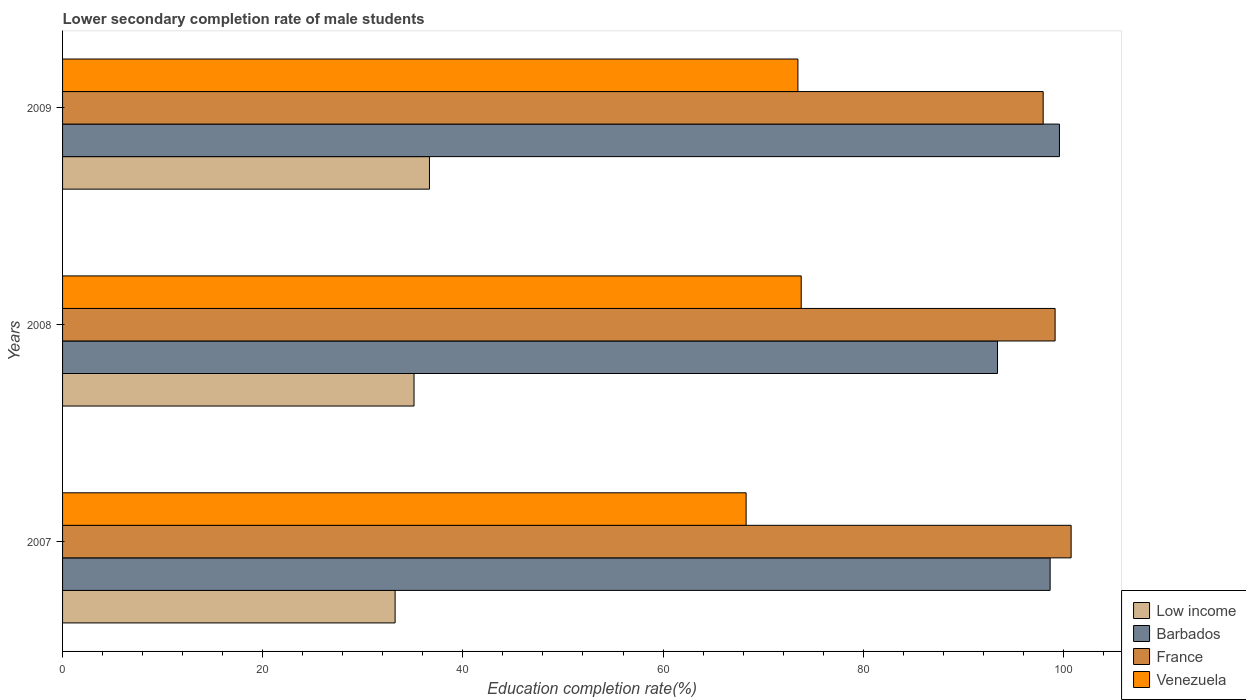How many bars are there on the 1st tick from the top?
Keep it short and to the point. 4. How many bars are there on the 2nd tick from the bottom?
Your answer should be very brief. 4. What is the label of the 1st group of bars from the top?
Provide a succinct answer. 2009. In how many cases, is the number of bars for a given year not equal to the number of legend labels?
Your answer should be compact. 0. What is the lower secondary completion rate of male students in Venezuela in 2007?
Provide a succinct answer. 68.3. Across all years, what is the maximum lower secondary completion rate of male students in Low income?
Your response must be concise. 36.66. Across all years, what is the minimum lower secondary completion rate of male students in Low income?
Keep it short and to the point. 33.23. In which year was the lower secondary completion rate of male students in France minimum?
Provide a succinct answer. 2009. What is the total lower secondary completion rate of male students in Barbados in the graph?
Offer a terse response. 291.71. What is the difference between the lower secondary completion rate of male students in Barbados in 2008 and that in 2009?
Ensure brevity in your answer.  -6.19. What is the difference between the lower secondary completion rate of male students in Venezuela in 2009 and the lower secondary completion rate of male students in Low income in 2007?
Give a very brief answer. 40.25. What is the average lower secondary completion rate of male students in Low income per year?
Offer a terse response. 35. In the year 2007, what is the difference between the lower secondary completion rate of male students in Barbados and lower secondary completion rate of male students in Low income?
Provide a succinct answer. 65.45. In how many years, is the lower secondary completion rate of male students in Low income greater than 80 %?
Your answer should be very brief. 0. What is the ratio of the lower secondary completion rate of male students in Barbados in 2008 to that in 2009?
Your response must be concise. 0.94. Is the difference between the lower secondary completion rate of male students in Barbados in 2008 and 2009 greater than the difference between the lower secondary completion rate of male students in Low income in 2008 and 2009?
Offer a very short reply. No. What is the difference between the highest and the second highest lower secondary completion rate of male students in Venezuela?
Your answer should be compact. 0.33. What is the difference between the highest and the lowest lower secondary completion rate of male students in Venezuela?
Make the answer very short. 5.5. Is the sum of the lower secondary completion rate of male students in Low income in 2007 and 2009 greater than the maximum lower secondary completion rate of male students in Barbados across all years?
Offer a very short reply. No. Is it the case that in every year, the sum of the lower secondary completion rate of male students in Low income and lower secondary completion rate of male students in Venezuela is greater than the sum of lower secondary completion rate of male students in France and lower secondary completion rate of male students in Barbados?
Keep it short and to the point. Yes. What does the 4th bar from the bottom in 2009 represents?
Provide a short and direct response. Venezuela. Is it the case that in every year, the sum of the lower secondary completion rate of male students in Venezuela and lower secondary completion rate of male students in France is greater than the lower secondary completion rate of male students in Low income?
Make the answer very short. Yes. How many bars are there?
Ensure brevity in your answer.  12. Are all the bars in the graph horizontal?
Provide a short and direct response. Yes. What is the difference between two consecutive major ticks on the X-axis?
Your answer should be compact. 20. Does the graph contain any zero values?
Offer a terse response. No. How many legend labels are there?
Make the answer very short. 4. What is the title of the graph?
Provide a succinct answer. Lower secondary completion rate of male students. What is the label or title of the X-axis?
Provide a succinct answer. Education completion rate(%). What is the label or title of the Y-axis?
Provide a short and direct response. Years. What is the Education completion rate(%) in Low income in 2007?
Give a very brief answer. 33.23. What is the Education completion rate(%) in Barbados in 2007?
Provide a short and direct response. 98.68. What is the Education completion rate(%) of France in 2007?
Make the answer very short. 100.78. What is the Education completion rate(%) in Venezuela in 2007?
Your answer should be compact. 68.3. What is the Education completion rate(%) in Low income in 2008?
Offer a terse response. 35.12. What is the Education completion rate(%) in Barbados in 2008?
Your response must be concise. 93.42. What is the Education completion rate(%) in France in 2008?
Give a very brief answer. 99.18. What is the Education completion rate(%) of Venezuela in 2008?
Give a very brief answer. 73.81. What is the Education completion rate(%) of Low income in 2009?
Give a very brief answer. 36.66. What is the Education completion rate(%) of Barbados in 2009?
Offer a terse response. 99.61. What is the Education completion rate(%) in France in 2009?
Your answer should be very brief. 97.98. What is the Education completion rate(%) of Venezuela in 2009?
Keep it short and to the point. 73.48. Across all years, what is the maximum Education completion rate(%) of Low income?
Make the answer very short. 36.66. Across all years, what is the maximum Education completion rate(%) of Barbados?
Provide a succinct answer. 99.61. Across all years, what is the maximum Education completion rate(%) in France?
Offer a terse response. 100.78. Across all years, what is the maximum Education completion rate(%) of Venezuela?
Ensure brevity in your answer.  73.81. Across all years, what is the minimum Education completion rate(%) of Low income?
Your response must be concise. 33.23. Across all years, what is the minimum Education completion rate(%) in Barbados?
Make the answer very short. 93.42. Across all years, what is the minimum Education completion rate(%) in France?
Offer a very short reply. 97.98. Across all years, what is the minimum Education completion rate(%) of Venezuela?
Make the answer very short. 68.3. What is the total Education completion rate(%) in Low income in the graph?
Provide a short and direct response. 105.01. What is the total Education completion rate(%) of Barbados in the graph?
Provide a short and direct response. 291.71. What is the total Education completion rate(%) of France in the graph?
Keep it short and to the point. 297.94. What is the total Education completion rate(%) in Venezuela in the graph?
Your response must be concise. 215.59. What is the difference between the Education completion rate(%) of Low income in 2007 and that in 2008?
Ensure brevity in your answer.  -1.89. What is the difference between the Education completion rate(%) in Barbados in 2007 and that in 2008?
Offer a very short reply. 5.26. What is the difference between the Education completion rate(%) of France in 2007 and that in 2008?
Keep it short and to the point. 1.6. What is the difference between the Education completion rate(%) in Venezuela in 2007 and that in 2008?
Your answer should be compact. -5.5. What is the difference between the Education completion rate(%) in Low income in 2007 and that in 2009?
Your response must be concise. -3.43. What is the difference between the Education completion rate(%) of Barbados in 2007 and that in 2009?
Your answer should be compact. -0.93. What is the difference between the Education completion rate(%) of France in 2007 and that in 2009?
Your response must be concise. 2.79. What is the difference between the Education completion rate(%) of Venezuela in 2007 and that in 2009?
Your response must be concise. -5.17. What is the difference between the Education completion rate(%) in Low income in 2008 and that in 2009?
Provide a succinct answer. -1.54. What is the difference between the Education completion rate(%) of Barbados in 2008 and that in 2009?
Make the answer very short. -6.19. What is the difference between the Education completion rate(%) in France in 2008 and that in 2009?
Offer a terse response. 1.19. What is the difference between the Education completion rate(%) in Venezuela in 2008 and that in 2009?
Your answer should be very brief. 0.33. What is the difference between the Education completion rate(%) of Low income in 2007 and the Education completion rate(%) of Barbados in 2008?
Make the answer very short. -60.19. What is the difference between the Education completion rate(%) in Low income in 2007 and the Education completion rate(%) in France in 2008?
Offer a very short reply. -65.95. What is the difference between the Education completion rate(%) of Low income in 2007 and the Education completion rate(%) of Venezuela in 2008?
Provide a short and direct response. -40.58. What is the difference between the Education completion rate(%) in Barbados in 2007 and the Education completion rate(%) in France in 2008?
Your response must be concise. -0.5. What is the difference between the Education completion rate(%) of Barbados in 2007 and the Education completion rate(%) of Venezuela in 2008?
Provide a short and direct response. 24.87. What is the difference between the Education completion rate(%) in France in 2007 and the Education completion rate(%) in Venezuela in 2008?
Offer a very short reply. 26.97. What is the difference between the Education completion rate(%) of Low income in 2007 and the Education completion rate(%) of Barbados in 2009?
Provide a short and direct response. -66.38. What is the difference between the Education completion rate(%) in Low income in 2007 and the Education completion rate(%) in France in 2009?
Your response must be concise. -64.76. What is the difference between the Education completion rate(%) of Low income in 2007 and the Education completion rate(%) of Venezuela in 2009?
Offer a terse response. -40.25. What is the difference between the Education completion rate(%) in Barbados in 2007 and the Education completion rate(%) in France in 2009?
Your answer should be very brief. 0.7. What is the difference between the Education completion rate(%) of Barbados in 2007 and the Education completion rate(%) of Venezuela in 2009?
Make the answer very short. 25.2. What is the difference between the Education completion rate(%) of France in 2007 and the Education completion rate(%) of Venezuela in 2009?
Provide a short and direct response. 27.3. What is the difference between the Education completion rate(%) of Low income in 2008 and the Education completion rate(%) of Barbados in 2009?
Make the answer very short. -64.49. What is the difference between the Education completion rate(%) in Low income in 2008 and the Education completion rate(%) in France in 2009?
Make the answer very short. -62.87. What is the difference between the Education completion rate(%) of Low income in 2008 and the Education completion rate(%) of Venezuela in 2009?
Ensure brevity in your answer.  -38.36. What is the difference between the Education completion rate(%) in Barbados in 2008 and the Education completion rate(%) in France in 2009?
Offer a terse response. -4.56. What is the difference between the Education completion rate(%) of Barbados in 2008 and the Education completion rate(%) of Venezuela in 2009?
Keep it short and to the point. 19.94. What is the difference between the Education completion rate(%) of France in 2008 and the Education completion rate(%) of Venezuela in 2009?
Offer a terse response. 25.7. What is the average Education completion rate(%) of Low income per year?
Provide a short and direct response. 35. What is the average Education completion rate(%) of Barbados per year?
Your answer should be very brief. 97.24. What is the average Education completion rate(%) of France per year?
Your answer should be compact. 99.31. What is the average Education completion rate(%) of Venezuela per year?
Ensure brevity in your answer.  71.86. In the year 2007, what is the difference between the Education completion rate(%) of Low income and Education completion rate(%) of Barbados?
Provide a short and direct response. -65.45. In the year 2007, what is the difference between the Education completion rate(%) in Low income and Education completion rate(%) in France?
Make the answer very short. -67.55. In the year 2007, what is the difference between the Education completion rate(%) in Low income and Education completion rate(%) in Venezuela?
Offer a terse response. -35.07. In the year 2007, what is the difference between the Education completion rate(%) of Barbados and Education completion rate(%) of France?
Your answer should be compact. -2.1. In the year 2007, what is the difference between the Education completion rate(%) of Barbados and Education completion rate(%) of Venezuela?
Offer a terse response. 30.38. In the year 2007, what is the difference between the Education completion rate(%) in France and Education completion rate(%) in Venezuela?
Your answer should be compact. 32.47. In the year 2008, what is the difference between the Education completion rate(%) of Low income and Education completion rate(%) of Barbados?
Provide a short and direct response. -58.3. In the year 2008, what is the difference between the Education completion rate(%) of Low income and Education completion rate(%) of France?
Offer a very short reply. -64.06. In the year 2008, what is the difference between the Education completion rate(%) in Low income and Education completion rate(%) in Venezuela?
Keep it short and to the point. -38.69. In the year 2008, what is the difference between the Education completion rate(%) of Barbados and Education completion rate(%) of France?
Ensure brevity in your answer.  -5.75. In the year 2008, what is the difference between the Education completion rate(%) in Barbados and Education completion rate(%) in Venezuela?
Offer a terse response. 19.61. In the year 2008, what is the difference between the Education completion rate(%) in France and Education completion rate(%) in Venezuela?
Your answer should be compact. 25.37. In the year 2009, what is the difference between the Education completion rate(%) of Low income and Education completion rate(%) of Barbados?
Your answer should be very brief. -62.95. In the year 2009, what is the difference between the Education completion rate(%) of Low income and Education completion rate(%) of France?
Keep it short and to the point. -61.32. In the year 2009, what is the difference between the Education completion rate(%) of Low income and Education completion rate(%) of Venezuela?
Keep it short and to the point. -36.82. In the year 2009, what is the difference between the Education completion rate(%) of Barbados and Education completion rate(%) of France?
Make the answer very short. 1.63. In the year 2009, what is the difference between the Education completion rate(%) of Barbados and Education completion rate(%) of Venezuela?
Keep it short and to the point. 26.13. In the year 2009, what is the difference between the Education completion rate(%) of France and Education completion rate(%) of Venezuela?
Offer a terse response. 24.51. What is the ratio of the Education completion rate(%) of Low income in 2007 to that in 2008?
Your response must be concise. 0.95. What is the ratio of the Education completion rate(%) in Barbados in 2007 to that in 2008?
Offer a terse response. 1.06. What is the ratio of the Education completion rate(%) of France in 2007 to that in 2008?
Offer a very short reply. 1.02. What is the ratio of the Education completion rate(%) of Venezuela in 2007 to that in 2008?
Give a very brief answer. 0.93. What is the ratio of the Education completion rate(%) of Low income in 2007 to that in 2009?
Give a very brief answer. 0.91. What is the ratio of the Education completion rate(%) in France in 2007 to that in 2009?
Make the answer very short. 1.03. What is the ratio of the Education completion rate(%) of Venezuela in 2007 to that in 2009?
Your answer should be very brief. 0.93. What is the ratio of the Education completion rate(%) in Low income in 2008 to that in 2009?
Make the answer very short. 0.96. What is the ratio of the Education completion rate(%) of Barbados in 2008 to that in 2009?
Provide a succinct answer. 0.94. What is the ratio of the Education completion rate(%) of France in 2008 to that in 2009?
Offer a very short reply. 1.01. What is the difference between the highest and the second highest Education completion rate(%) of Low income?
Give a very brief answer. 1.54. What is the difference between the highest and the second highest Education completion rate(%) of Barbados?
Offer a very short reply. 0.93. What is the difference between the highest and the second highest Education completion rate(%) in France?
Offer a terse response. 1.6. What is the difference between the highest and the second highest Education completion rate(%) in Venezuela?
Your answer should be very brief. 0.33. What is the difference between the highest and the lowest Education completion rate(%) of Low income?
Your answer should be very brief. 3.43. What is the difference between the highest and the lowest Education completion rate(%) of Barbados?
Your answer should be very brief. 6.19. What is the difference between the highest and the lowest Education completion rate(%) of France?
Give a very brief answer. 2.79. What is the difference between the highest and the lowest Education completion rate(%) in Venezuela?
Offer a terse response. 5.5. 